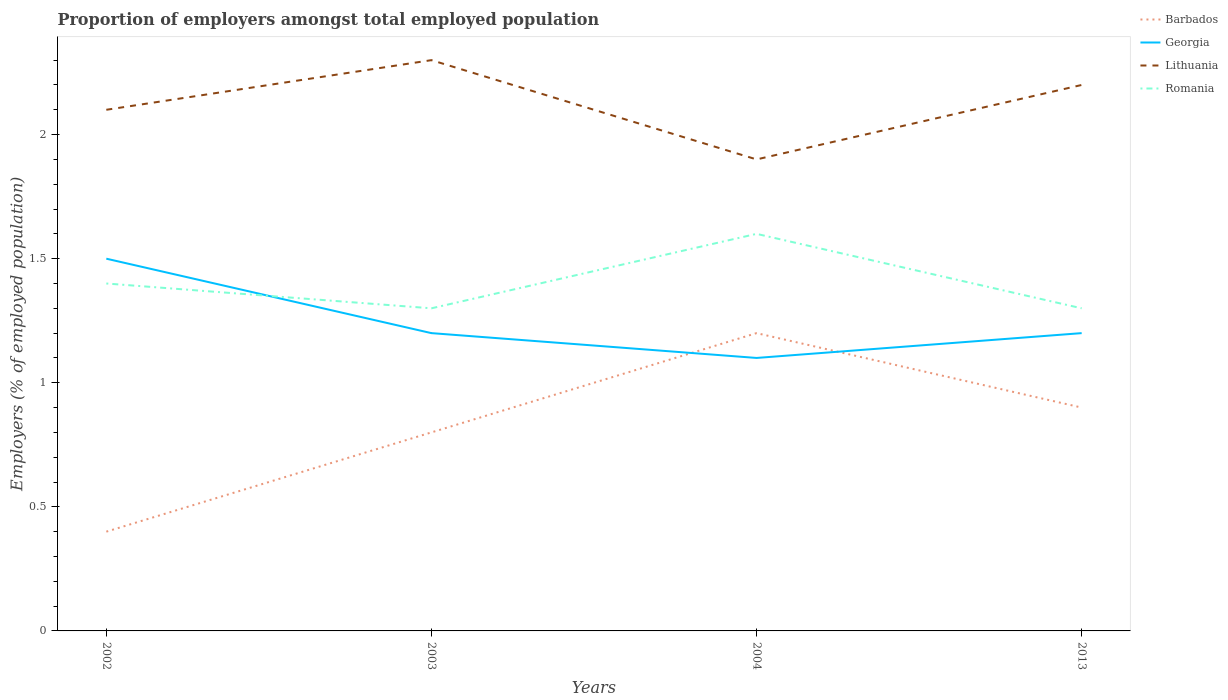Does the line corresponding to Barbados intersect with the line corresponding to Georgia?
Give a very brief answer. Yes. Is the number of lines equal to the number of legend labels?
Make the answer very short. Yes. Across all years, what is the maximum proportion of employers in Georgia?
Keep it short and to the point. 1.1. What is the total proportion of employers in Romania in the graph?
Make the answer very short. -0.3. What is the difference between the highest and the second highest proportion of employers in Georgia?
Give a very brief answer. 0.4. What is the difference between the highest and the lowest proportion of employers in Lithuania?
Ensure brevity in your answer.  2. Is the proportion of employers in Romania strictly greater than the proportion of employers in Georgia over the years?
Keep it short and to the point. No. How many lines are there?
Provide a succinct answer. 4. How many years are there in the graph?
Keep it short and to the point. 4. Are the values on the major ticks of Y-axis written in scientific E-notation?
Your answer should be compact. No. Does the graph contain grids?
Provide a short and direct response. No. What is the title of the graph?
Make the answer very short. Proportion of employers amongst total employed population. What is the label or title of the X-axis?
Offer a very short reply. Years. What is the label or title of the Y-axis?
Your answer should be very brief. Employers (% of employed population). What is the Employers (% of employed population) in Barbados in 2002?
Ensure brevity in your answer.  0.4. What is the Employers (% of employed population) in Lithuania in 2002?
Provide a succinct answer. 2.1. What is the Employers (% of employed population) in Romania in 2002?
Offer a terse response. 1.4. What is the Employers (% of employed population) in Barbados in 2003?
Offer a terse response. 0.8. What is the Employers (% of employed population) of Georgia in 2003?
Ensure brevity in your answer.  1.2. What is the Employers (% of employed population) of Lithuania in 2003?
Give a very brief answer. 2.3. What is the Employers (% of employed population) in Romania in 2003?
Keep it short and to the point. 1.3. What is the Employers (% of employed population) in Barbados in 2004?
Ensure brevity in your answer.  1.2. What is the Employers (% of employed population) in Georgia in 2004?
Provide a short and direct response. 1.1. What is the Employers (% of employed population) of Lithuania in 2004?
Your response must be concise. 1.9. What is the Employers (% of employed population) in Romania in 2004?
Ensure brevity in your answer.  1.6. What is the Employers (% of employed population) in Barbados in 2013?
Provide a succinct answer. 0.9. What is the Employers (% of employed population) of Georgia in 2013?
Offer a very short reply. 1.2. What is the Employers (% of employed population) in Lithuania in 2013?
Offer a terse response. 2.2. What is the Employers (% of employed population) in Romania in 2013?
Keep it short and to the point. 1.3. Across all years, what is the maximum Employers (% of employed population) in Barbados?
Give a very brief answer. 1.2. Across all years, what is the maximum Employers (% of employed population) in Georgia?
Give a very brief answer. 1.5. Across all years, what is the maximum Employers (% of employed population) of Lithuania?
Your answer should be very brief. 2.3. Across all years, what is the maximum Employers (% of employed population) of Romania?
Your answer should be compact. 1.6. Across all years, what is the minimum Employers (% of employed population) in Barbados?
Provide a short and direct response. 0.4. Across all years, what is the minimum Employers (% of employed population) of Georgia?
Give a very brief answer. 1.1. Across all years, what is the minimum Employers (% of employed population) of Lithuania?
Your answer should be very brief. 1.9. Across all years, what is the minimum Employers (% of employed population) of Romania?
Keep it short and to the point. 1.3. What is the total Employers (% of employed population) in Barbados in the graph?
Make the answer very short. 3.3. What is the total Employers (% of employed population) of Georgia in the graph?
Offer a very short reply. 5. What is the difference between the Employers (% of employed population) in Georgia in 2002 and that in 2003?
Offer a terse response. 0.3. What is the difference between the Employers (% of employed population) of Lithuania in 2002 and that in 2003?
Your response must be concise. -0.2. What is the difference between the Employers (% of employed population) of Romania in 2002 and that in 2003?
Offer a very short reply. 0.1. What is the difference between the Employers (% of employed population) of Barbados in 2002 and that in 2004?
Provide a short and direct response. -0.8. What is the difference between the Employers (% of employed population) in Georgia in 2002 and that in 2004?
Provide a succinct answer. 0.4. What is the difference between the Employers (% of employed population) of Lithuania in 2002 and that in 2004?
Your answer should be very brief. 0.2. What is the difference between the Employers (% of employed population) of Romania in 2002 and that in 2004?
Give a very brief answer. -0.2. What is the difference between the Employers (% of employed population) of Barbados in 2002 and that in 2013?
Your answer should be very brief. -0.5. What is the difference between the Employers (% of employed population) of Barbados in 2003 and that in 2004?
Make the answer very short. -0.4. What is the difference between the Employers (% of employed population) in Georgia in 2003 and that in 2004?
Your answer should be compact. 0.1. What is the difference between the Employers (% of employed population) of Lithuania in 2003 and that in 2004?
Your answer should be compact. 0.4. What is the difference between the Employers (% of employed population) of Barbados in 2004 and that in 2013?
Your response must be concise. 0.3. What is the difference between the Employers (% of employed population) in Georgia in 2004 and that in 2013?
Your answer should be compact. -0.1. What is the difference between the Employers (% of employed population) in Lithuania in 2004 and that in 2013?
Your answer should be compact. -0.3. What is the difference between the Employers (% of employed population) of Romania in 2004 and that in 2013?
Your response must be concise. 0.3. What is the difference between the Employers (% of employed population) in Barbados in 2002 and the Employers (% of employed population) in Georgia in 2003?
Offer a very short reply. -0.8. What is the difference between the Employers (% of employed population) of Barbados in 2002 and the Employers (% of employed population) of Romania in 2003?
Provide a short and direct response. -0.9. What is the difference between the Employers (% of employed population) of Georgia in 2002 and the Employers (% of employed population) of Lithuania in 2003?
Make the answer very short. -0.8. What is the difference between the Employers (% of employed population) in Georgia in 2002 and the Employers (% of employed population) in Romania in 2003?
Make the answer very short. 0.2. What is the difference between the Employers (% of employed population) in Barbados in 2002 and the Employers (% of employed population) in Romania in 2004?
Your answer should be very brief. -1.2. What is the difference between the Employers (% of employed population) of Georgia in 2002 and the Employers (% of employed population) of Romania in 2004?
Your response must be concise. -0.1. What is the difference between the Employers (% of employed population) of Georgia in 2002 and the Employers (% of employed population) of Lithuania in 2013?
Your answer should be compact. -0.7. What is the difference between the Employers (% of employed population) in Barbados in 2003 and the Employers (% of employed population) in Romania in 2004?
Make the answer very short. -0.8. What is the difference between the Employers (% of employed population) in Georgia in 2003 and the Employers (% of employed population) in Lithuania in 2004?
Offer a very short reply. -0.7. What is the difference between the Employers (% of employed population) of Barbados in 2003 and the Employers (% of employed population) of Georgia in 2013?
Give a very brief answer. -0.4. What is the difference between the Employers (% of employed population) of Barbados in 2003 and the Employers (% of employed population) of Romania in 2013?
Your answer should be very brief. -0.5. What is the difference between the Employers (% of employed population) in Georgia in 2003 and the Employers (% of employed population) in Lithuania in 2013?
Offer a terse response. -1. What is the difference between the Employers (% of employed population) in Lithuania in 2003 and the Employers (% of employed population) in Romania in 2013?
Offer a very short reply. 1. What is the difference between the Employers (% of employed population) in Barbados in 2004 and the Employers (% of employed population) in Lithuania in 2013?
Keep it short and to the point. -1. What is the difference between the Employers (% of employed population) of Georgia in 2004 and the Employers (% of employed population) of Lithuania in 2013?
Provide a succinct answer. -1.1. What is the difference between the Employers (% of employed population) of Georgia in 2004 and the Employers (% of employed population) of Romania in 2013?
Offer a very short reply. -0.2. What is the average Employers (% of employed population) of Barbados per year?
Your answer should be compact. 0.82. What is the average Employers (% of employed population) of Lithuania per year?
Keep it short and to the point. 2.12. In the year 2002, what is the difference between the Employers (% of employed population) of Barbados and Employers (% of employed population) of Romania?
Offer a very short reply. -1. In the year 2002, what is the difference between the Employers (% of employed population) in Georgia and Employers (% of employed population) in Romania?
Your response must be concise. 0.1. In the year 2003, what is the difference between the Employers (% of employed population) of Barbados and Employers (% of employed population) of Georgia?
Your answer should be compact. -0.4. In the year 2003, what is the difference between the Employers (% of employed population) in Barbados and Employers (% of employed population) in Romania?
Make the answer very short. -0.5. In the year 2004, what is the difference between the Employers (% of employed population) in Barbados and Employers (% of employed population) in Georgia?
Ensure brevity in your answer.  0.1. In the year 2004, what is the difference between the Employers (% of employed population) of Barbados and Employers (% of employed population) of Romania?
Offer a terse response. -0.4. In the year 2004, what is the difference between the Employers (% of employed population) of Georgia and Employers (% of employed population) of Lithuania?
Give a very brief answer. -0.8. In the year 2004, what is the difference between the Employers (% of employed population) in Georgia and Employers (% of employed population) in Romania?
Keep it short and to the point. -0.5. In the year 2004, what is the difference between the Employers (% of employed population) of Lithuania and Employers (% of employed population) of Romania?
Your answer should be very brief. 0.3. In the year 2013, what is the difference between the Employers (% of employed population) of Barbados and Employers (% of employed population) of Lithuania?
Give a very brief answer. -1.3. In the year 2013, what is the difference between the Employers (% of employed population) in Barbados and Employers (% of employed population) in Romania?
Offer a terse response. -0.4. In the year 2013, what is the difference between the Employers (% of employed population) in Georgia and Employers (% of employed population) in Romania?
Your response must be concise. -0.1. What is the ratio of the Employers (% of employed population) of Georgia in 2002 to that in 2003?
Your answer should be very brief. 1.25. What is the ratio of the Employers (% of employed population) in Lithuania in 2002 to that in 2003?
Your answer should be compact. 0.91. What is the ratio of the Employers (% of employed population) in Georgia in 2002 to that in 2004?
Your response must be concise. 1.36. What is the ratio of the Employers (% of employed population) of Lithuania in 2002 to that in 2004?
Ensure brevity in your answer.  1.11. What is the ratio of the Employers (% of employed population) of Barbados in 2002 to that in 2013?
Ensure brevity in your answer.  0.44. What is the ratio of the Employers (% of employed population) in Lithuania in 2002 to that in 2013?
Keep it short and to the point. 0.95. What is the ratio of the Employers (% of employed population) of Romania in 2002 to that in 2013?
Offer a very short reply. 1.08. What is the ratio of the Employers (% of employed population) in Lithuania in 2003 to that in 2004?
Offer a terse response. 1.21. What is the ratio of the Employers (% of employed population) of Romania in 2003 to that in 2004?
Make the answer very short. 0.81. What is the ratio of the Employers (% of employed population) in Barbados in 2003 to that in 2013?
Your answer should be very brief. 0.89. What is the ratio of the Employers (% of employed population) of Georgia in 2003 to that in 2013?
Ensure brevity in your answer.  1. What is the ratio of the Employers (% of employed population) of Lithuania in 2003 to that in 2013?
Give a very brief answer. 1.05. What is the ratio of the Employers (% of employed population) in Barbados in 2004 to that in 2013?
Your answer should be very brief. 1.33. What is the ratio of the Employers (% of employed population) in Lithuania in 2004 to that in 2013?
Provide a short and direct response. 0.86. What is the ratio of the Employers (% of employed population) in Romania in 2004 to that in 2013?
Give a very brief answer. 1.23. What is the difference between the highest and the second highest Employers (% of employed population) in Barbados?
Give a very brief answer. 0.3. What is the difference between the highest and the lowest Employers (% of employed population) of Georgia?
Your response must be concise. 0.4. 